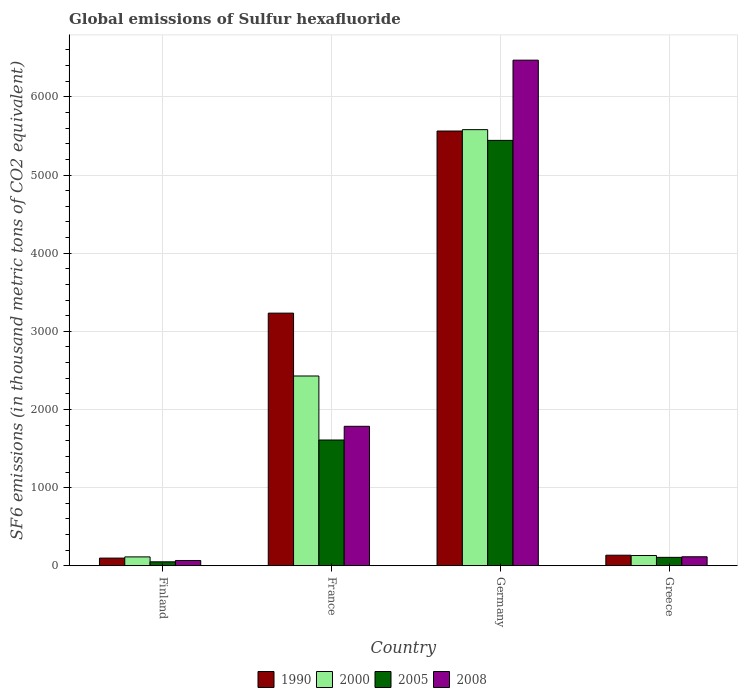How many different coloured bars are there?
Ensure brevity in your answer.  4. How many groups of bars are there?
Your answer should be very brief. 4. Are the number of bars per tick equal to the number of legend labels?
Your answer should be very brief. Yes. Are the number of bars on each tick of the X-axis equal?
Your answer should be compact. Yes. How many bars are there on the 3rd tick from the left?
Offer a very short reply. 4. What is the label of the 1st group of bars from the left?
Provide a succinct answer. Finland. What is the global emissions of Sulfur hexafluoride in 2000 in France?
Provide a short and direct response. 2428.5. Across all countries, what is the maximum global emissions of Sulfur hexafluoride in 2000?
Your response must be concise. 5580.4. Across all countries, what is the minimum global emissions of Sulfur hexafluoride in 2008?
Provide a short and direct response. 67.9. In which country was the global emissions of Sulfur hexafluoride in 2008 maximum?
Offer a very short reply. Germany. In which country was the global emissions of Sulfur hexafluoride in 2005 minimum?
Your answer should be very brief. Finland. What is the total global emissions of Sulfur hexafluoride in 2000 in the graph?
Your answer should be very brief. 8254.6. What is the difference between the global emissions of Sulfur hexafluoride in 2000 in Germany and that in Greece?
Your answer should be compact. 5448.6. What is the difference between the global emissions of Sulfur hexafluoride in 1990 in France and the global emissions of Sulfur hexafluoride in 2008 in Greece?
Offer a very short reply. 3117.4. What is the average global emissions of Sulfur hexafluoride in 1990 per country?
Your response must be concise. 2257.38. What is the difference between the global emissions of Sulfur hexafluoride of/in 2000 and global emissions of Sulfur hexafluoride of/in 2005 in Finland?
Your answer should be very brief. 63. What is the ratio of the global emissions of Sulfur hexafluoride in 2008 in Finland to that in France?
Give a very brief answer. 0.04. Is the difference between the global emissions of Sulfur hexafluoride in 2000 in Germany and Greece greater than the difference between the global emissions of Sulfur hexafluoride in 2005 in Germany and Greece?
Provide a succinct answer. Yes. What is the difference between the highest and the second highest global emissions of Sulfur hexafluoride in 2005?
Your response must be concise. -3833.8. What is the difference between the highest and the lowest global emissions of Sulfur hexafluoride in 2005?
Offer a terse response. 5392.3. In how many countries, is the global emissions of Sulfur hexafluoride in 2008 greater than the average global emissions of Sulfur hexafluoride in 2008 taken over all countries?
Your answer should be very brief. 1. What does the 2nd bar from the right in France represents?
Your response must be concise. 2005. How many bars are there?
Provide a succinct answer. 16. What is the difference between two consecutive major ticks on the Y-axis?
Your answer should be compact. 1000. Where does the legend appear in the graph?
Ensure brevity in your answer.  Bottom center. How are the legend labels stacked?
Offer a terse response. Horizontal. What is the title of the graph?
Give a very brief answer. Global emissions of Sulfur hexafluoride. What is the label or title of the X-axis?
Offer a very short reply. Country. What is the label or title of the Y-axis?
Your answer should be very brief. SF6 emissions (in thousand metric tons of CO2 equivalent). What is the SF6 emissions (in thousand metric tons of CO2 equivalent) of 1990 in Finland?
Offer a very short reply. 98.4. What is the SF6 emissions (in thousand metric tons of CO2 equivalent) of 2000 in Finland?
Keep it short and to the point. 113.9. What is the SF6 emissions (in thousand metric tons of CO2 equivalent) in 2005 in Finland?
Your answer should be compact. 50.9. What is the SF6 emissions (in thousand metric tons of CO2 equivalent) of 2008 in Finland?
Ensure brevity in your answer.  67.9. What is the SF6 emissions (in thousand metric tons of CO2 equivalent) in 1990 in France?
Make the answer very short. 3232.8. What is the SF6 emissions (in thousand metric tons of CO2 equivalent) of 2000 in France?
Provide a short and direct response. 2428.5. What is the SF6 emissions (in thousand metric tons of CO2 equivalent) of 2005 in France?
Make the answer very short. 1609.4. What is the SF6 emissions (in thousand metric tons of CO2 equivalent) of 2008 in France?
Your response must be concise. 1784.7. What is the SF6 emissions (in thousand metric tons of CO2 equivalent) in 1990 in Germany?
Offer a terse response. 5562.9. What is the SF6 emissions (in thousand metric tons of CO2 equivalent) in 2000 in Germany?
Your response must be concise. 5580.4. What is the SF6 emissions (in thousand metric tons of CO2 equivalent) of 2005 in Germany?
Your answer should be compact. 5443.2. What is the SF6 emissions (in thousand metric tons of CO2 equivalent) of 2008 in Germany?
Offer a terse response. 6469.6. What is the SF6 emissions (in thousand metric tons of CO2 equivalent) in 1990 in Greece?
Your answer should be very brief. 135.4. What is the SF6 emissions (in thousand metric tons of CO2 equivalent) of 2000 in Greece?
Ensure brevity in your answer.  131.8. What is the SF6 emissions (in thousand metric tons of CO2 equivalent) of 2005 in Greece?
Offer a terse response. 108.1. What is the SF6 emissions (in thousand metric tons of CO2 equivalent) of 2008 in Greece?
Give a very brief answer. 115.4. Across all countries, what is the maximum SF6 emissions (in thousand metric tons of CO2 equivalent) in 1990?
Provide a succinct answer. 5562.9. Across all countries, what is the maximum SF6 emissions (in thousand metric tons of CO2 equivalent) of 2000?
Make the answer very short. 5580.4. Across all countries, what is the maximum SF6 emissions (in thousand metric tons of CO2 equivalent) of 2005?
Your answer should be compact. 5443.2. Across all countries, what is the maximum SF6 emissions (in thousand metric tons of CO2 equivalent) of 2008?
Offer a terse response. 6469.6. Across all countries, what is the minimum SF6 emissions (in thousand metric tons of CO2 equivalent) in 1990?
Keep it short and to the point. 98.4. Across all countries, what is the minimum SF6 emissions (in thousand metric tons of CO2 equivalent) of 2000?
Ensure brevity in your answer.  113.9. Across all countries, what is the minimum SF6 emissions (in thousand metric tons of CO2 equivalent) in 2005?
Your response must be concise. 50.9. Across all countries, what is the minimum SF6 emissions (in thousand metric tons of CO2 equivalent) in 2008?
Offer a very short reply. 67.9. What is the total SF6 emissions (in thousand metric tons of CO2 equivalent) of 1990 in the graph?
Ensure brevity in your answer.  9029.5. What is the total SF6 emissions (in thousand metric tons of CO2 equivalent) of 2000 in the graph?
Keep it short and to the point. 8254.6. What is the total SF6 emissions (in thousand metric tons of CO2 equivalent) in 2005 in the graph?
Your response must be concise. 7211.6. What is the total SF6 emissions (in thousand metric tons of CO2 equivalent) in 2008 in the graph?
Give a very brief answer. 8437.6. What is the difference between the SF6 emissions (in thousand metric tons of CO2 equivalent) in 1990 in Finland and that in France?
Offer a very short reply. -3134.4. What is the difference between the SF6 emissions (in thousand metric tons of CO2 equivalent) of 2000 in Finland and that in France?
Make the answer very short. -2314.6. What is the difference between the SF6 emissions (in thousand metric tons of CO2 equivalent) of 2005 in Finland and that in France?
Give a very brief answer. -1558.5. What is the difference between the SF6 emissions (in thousand metric tons of CO2 equivalent) in 2008 in Finland and that in France?
Keep it short and to the point. -1716.8. What is the difference between the SF6 emissions (in thousand metric tons of CO2 equivalent) in 1990 in Finland and that in Germany?
Your answer should be compact. -5464.5. What is the difference between the SF6 emissions (in thousand metric tons of CO2 equivalent) in 2000 in Finland and that in Germany?
Give a very brief answer. -5466.5. What is the difference between the SF6 emissions (in thousand metric tons of CO2 equivalent) in 2005 in Finland and that in Germany?
Provide a succinct answer. -5392.3. What is the difference between the SF6 emissions (in thousand metric tons of CO2 equivalent) of 2008 in Finland and that in Germany?
Give a very brief answer. -6401.7. What is the difference between the SF6 emissions (in thousand metric tons of CO2 equivalent) of 1990 in Finland and that in Greece?
Make the answer very short. -37. What is the difference between the SF6 emissions (in thousand metric tons of CO2 equivalent) of 2000 in Finland and that in Greece?
Keep it short and to the point. -17.9. What is the difference between the SF6 emissions (in thousand metric tons of CO2 equivalent) in 2005 in Finland and that in Greece?
Keep it short and to the point. -57.2. What is the difference between the SF6 emissions (in thousand metric tons of CO2 equivalent) in 2008 in Finland and that in Greece?
Offer a very short reply. -47.5. What is the difference between the SF6 emissions (in thousand metric tons of CO2 equivalent) in 1990 in France and that in Germany?
Ensure brevity in your answer.  -2330.1. What is the difference between the SF6 emissions (in thousand metric tons of CO2 equivalent) of 2000 in France and that in Germany?
Offer a very short reply. -3151.9. What is the difference between the SF6 emissions (in thousand metric tons of CO2 equivalent) in 2005 in France and that in Germany?
Make the answer very short. -3833.8. What is the difference between the SF6 emissions (in thousand metric tons of CO2 equivalent) in 2008 in France and that in Germany?
Your response must be concise. -4684.9. What is the difference between the SF6 emissions (in thousand metric tons of CO2 equivalent) in 1990 in France and that in Greece?
Your response must be concise. 3097.4. What is the difference between the SF6 emissions (in thousand metric tons of CO2 equivalent) of 2000 in France and that in Greece?
Your answer should be compact. 2296.7. What is the difference between the SF6 emissions (in thousand metric tons of CO2 equivalent) in 2005 in France and that in Greece?
Your answer should be very brief. 1501.3. What is the difference between the SF6 emissions (in thousand metric tons of CO2 equivalent) in 2008 in France and that in Greece?
Provide a short and direct response. 1669.3. What is the difference between the SF6 emissions (in thousand metric tons of CO2 equivalent) of 1990 in Germany and that in Greece?
Make the answer very short. 5427.5. What is the difference between the SF6 emissions (in thousand metric tons of CO2 equivalent) in 2000 in Germany and that in Greece?
Make the answer very short. 5448.6. What is the difference between the SF6 emissions (in thousand metric tons of CO2 equivalent) of 2005 in Germany and that in Greece?
Offer a very short reply. 5335.1. What is the difference between the SF6 emissions (in thousand metric tons of CO2 equivalent) in 2008 in Germany and that in Greece?
Provide a short and direct response. 6354.2. What is the difference between the SF6 emissions (in thousand metric tons of CO2 equivalent) in 1990 in Finland and the SF6 emissions (in thousand metric tons of CO2 equivalent) in 2000 in France?
Give a very brief answer. -2330.1. What is the difference between the SF6 emissions (in thousand metric tons of CO2 equivalent) of 1990 in Finland and the SF6 emissions (in thousand metric tons of CO2 equivalent) of 2005 in France?
Give a very brief answer. -1511. What is the difference between the SF6 emissions (in thousand metric tons of CO2 equivalent) of 1990 in Finland and the SF6 emissions (in thousand metric tons of CO2 equivalent) of 2008 in France?
Your response must be concise. -1686.3. What is the difference between the SF6 emissions (in thousand metric tons of CO2 equivalent) in 2000 in Finland and the SF6 emissions (in thousand metric tons of CO2 equivalent) in 2005 in France?
Provide a short and direct response. -1495.5. What is the difference between the SF6 emissions (in thousand metric tons of CO2 equivalent) in 2000 in Finland and the SF6 emissions (in thousand metric tons of CO2 equivalent) in 2008 in France?
Your response must be concise. -1670.8. What is the difference between the SF6 emissions (in thousand metric tons of CO2 equivalent) of 2005 in Finland and the SF6 emissions (in thousand metric tons of CO2 equivalent) of 2008 in France?
Ensure brevity in your answer.  -1733.8. What is the difference between the SF6 emissions (in thousand metric tons of CO2 equivalent) in 1990 in Finland and the SF6 emissions (in thousand metric tons of CO2 equivalent) in 2000 in Germany?
Your answer should be very brief. -5482. What is the difference between the SF6 emissions (in thousand metric tons of CO2 equivalent) of 1990 in Finland and the SF6 emissions (in thousand metric tons of CO2 equivalent) of 2005 in Germany?
Your answer should be compact. -5344.8. What is the difference between the SF6 emissions (in thousand metric tons of CO2 equivalent) of 1990 in Finland and the SF6 emissions (in thousand metric tons of CO2 equivalent) of 2008 in Germany?
Give a very brief answer. -6371.2. What is the difference between the SF6 emissions (in thousand metric tons of CO2 equivalent) in 2000 in Finland and the SF6 emissions (in thousand metric tons of CO2 equivalent) in 2005 in Germany?
Keep it short and to the point. -5329.3. What is the difference between the SF6 emissions (in thousand metric tons of CO2 equivalent) of 2000 in Finland and the SF6 emissions (in thousand metric tons of CO2 equivalent) of 2008 in Germany?
Provide a succinct answer. -6355.7. What is the difference between the SF6 emissions (in thousand metric tons of CO2 equivalent) in 2005 in Finland and the SF6 emissions (in thousand metric tons of CO2 equivalent) in 2008 in Germany?
Your answer should be compact. -6418.7. What is the difference between the SF6 emissions (in thousand metric tons of CO2 equivalent) in 1990 in Finland and the SF6 emissions (in thousand metric tons of CO2 equivalent) in 2000 in Greece?
Your answer should be compact. -33.4. What is the difference between the SF6 emissions (in thousand metric tons of CO2 equivalent) of 2000 in Finland and the SF6 emissions (in thousand metric tons of CO2 equivalent) of 2005 in Greece?
Give a very brief answer. 5.8. What is the difference between the SF6 emissions (in thousand metric tons of CO2 equivalent) in 2000 in Finland and the SF6 emissions (in thousand metric tons of CO2 equivalent) in 2008 in Greece?
Make the answer very short. -1.5. What is the difference between the SF6 emissions (in thousand metric tons of CO2 equivalent) of 2005 in Finland and the SF6 emissions (in thousand metric tons of CO2 equivalent) of 2008 in Greece?
Your answer should be very brief. -64.5. What is the difference between the SF6 emissions (in thousand metric tons of CO2 equivalent) in 1990 in France and the SF6 emissions (in thousand metric tons of CO2 equivalent) in 2000 in Germany?
Ensure brevity in your answer.  -2347.6. What is the difference between the SF6 emissions (in thousand metric tons of CO2 equivalent) of 1990 in France and the SF6 emissions (in thousand metric tons of CO2 equivalent) of 2005 in Germany?
Give a very brief answer. -2210.4. What is the difference between the SF6 emissions (in thousand metric tons of CO2 equivalent) of 1990 in France and the SF6 emissions (in thousand metric tons of CO2 equivalent) of 2008 in Germany?
Give a very brief answer. -3236.8. What is the difference between the SF6 emissions (in thousand metric tons of CO2 equivalent) of 2000 in France and the SF6 emissions (in thousand metric tons of CO2 equivalent) of 2005 in Germany?
Keep it short and to the point. -3014.7. What is the difference between the SF6 emissions (in thousand metric tons of CO2 equivalent) of 2000 in France and the SF6 emissions (in thousand metric tons of CO2 equivalent) of 2008 in Germany?
Give a very brief answer. -4041.1. What is the difference between the SF6 emissions (in thousand metric tons of CO2 equivalent) in 2005 in France and the SF6 emissions (in thousand metric tons of CO2 equivalent) in 2008 in Germany?
Give a very brief answer. -4860.2. What is the difference between the SF6 emissions (in thousand metric tons of CO2 equivalent) in 1990 in France and the SF6 emissions (in thousand metric tons of CO2 equivalent) in 2000 in Greece?
Your answer should be very brief. 3101. What is the difference between the SF6 emissions (in thousand metric tons of CO2 equivalent) in 1990 in France and the SF6 emissions (in thousand metric tons of CO2 equivalent) in 2005 in Greece?
Offer a very short reply. 3124.7. What is the difference between the SF6 emissions (in thousand metric tons of CO2 equivalent) in 1990 in France and the SF6 emissions (in thousand metric tons of CO2 equivalent) in 2008 in Greece?
Your answer should be compact. 3117.4. What is the difference between the SF6 emissions (in thousand metric tons of CO2 equivalent) of 2000 in France and the SF6 emissions (in thousand metric tons of CO2 equivalent) of 2005 in Greece?
Give a very brief answer. 2320.4. What is the difference between the SF6 emissions (in thousand metric tons of CO2 equivalent) of 2000 in France and the SF6 emissions (in thousand metric tons of CO2 equivalent) of 2008 in Greece?
Provide a succinct answer. 2313.1. What is the difference between the SF6 emissions (in thousand metric tons of CO2 equivalent) in 2005 in France and the SF6 emissions (in thousand metric tons of CO2 equivalent) in 2008 in Greece?
Provide a succinct answer. 1494. What is the difference between the SF6 emissions (in thousand metric tons of CO2 equivalent) of 1990 in Germany and the SF6 emissions (in thousand metric tons of CO2 equivalent) of 2000 in Greece?
Provide a succinct answer. 5431.1. What is the difference between the SF6 emissions (in thousand metric tons of CO2 equivalent) in 1990 in Germany and the SF6 emissions (in thousand metric tons of CO2 equivalent) in 2005 in Greece?
Offer a terse response. 5454.8. What is the difference between the SF6 emissions (in thousand metric tons of CO2 equivalent) in 1990 in Germany and the SF6 emissions (in thousand metric tons of CO2 equivalent) in 2008 in Greece?
Ensure brevity in your answer.  5447.5. What is the difference between the SF6 emissions (in thousand metric tons of CO2 equivalent) in 2000 in Germany and the SF6 emissions (in thousand metric tons of CO2 equivalent) in 2005 in Greece?
Offer a very short reply. 5472.3. What is the difference between the SF6 emissions (in thousand metric tons of CO2 equivalent) in 2000 in Germany and the SF6 emissions (in thousand metric tons of CO2 equivalent) in 2008 in Greece?
Provide a succinct answer. 5465. What is the difference between the SF6 emissions (in thousand metric tons of CO2 equivalent) in 2005 in Germany and the SF6 emissions (in thousand metric tons of CO2 equivalent) in 2008 in Greece?
Provide a short and direct response. 5327.8. What is the average SF6 emissions (in thousand metric tons of CO2 equivalent) of 1990 per country?
Offer a terse response. 2257.38. What is the average SF6 emissions (in thousand metric tons of CO2 equivalent) in 2000 per country?
Your answer should be compact. 2063.65. What is the average SF6 emissions (in thousand metric tons of CO2 equivalent) of 2005 per country?
Your answer should be compact. 1802.9. What is the average SF6 emissions (in thousand metric tons of CO2 equivalent) in 2008 per country?
Make the answer very short. 2109.4. What is the difference between the SF6 emissions (in thousand metric tons of CO2 equivalent) in 1990 and SF6 emissions (in thousand metric tons of CO2 equivalent) in 2000 in Finland?
Give a very brief answer. -15.5. What is the difference between the SF6 emissions (in thousand metric tons of CO2 equivalent) in 1990 and SF6 emissions (in thousand metric tons of CO2 equivalent) in 2005 in Finland?
Make the answer very short. 47.5. What is the difference between the SF6 emissions (in thousand metric tons of CO2 equivalent) of 1990 and SF6 emissions (in thousand metric tons of CO2 equivalent) of 2008 in Finland?
Provide a short and direct response. 30.5. What is the difference between the SF6 emissions (in thousand metric tons of CO2 equivalent) of 2000 and SF6 emissions (in thousand metric tons of CO2 equivalent) of 2005 in Finland?
Your answer should be very brief. 63. What is the difference between the SF6 emissions (in thousand metric tons of CO2 equivalent) of 2005 and SF6 emissions (in thousand metric tons of CO2 equivalent) of 2008 in Finland?
Provide a succinct answer. -17. What is the difference between the SF6 emissions (in thousand metric tons of CO2 equivalent) of 1990 and SF6 emissions (in thousand metric tons of CO2 equivalent) of 2000 in France?
Your response must be concise. 804.3. What is the difference between the SF6 emissions (in thousand metric tons of CO2 equivalent) of 1990 and SF6 emissions (in thousand metric tons of CO2 equivalent) of 2005 in France?
Provide a short and direct response. 1623.4. What is the difference between the SF6 emissions (in thousand metric tons of CO2 equivalent) in 1990 and SF6 emissions (in thousand metric tons of CO2 equivalent) in 2008 in France?
Give a very brief answer. 1448.1. What is the difference between the SF6 emissions (in thousand metric tons of CO2 equivalent) of 2000 and SF6 emissions (in thousand metric tons of CO2 equivalent) of 2005 in France?
Offer a very short reply. 819.1. What is the difference between the SF6 emissions (in thousand metric tons of CO2 equivalent) in 2000 and SF6 emissions (in thousand metric tons of CO2 equivalent) in 2008 in France?
Provide a short and direct response. 643.8. What is the difference between the SF6 emissions (in thousand metric tons of CO2 equivalent) in 2005 and SF6 emissions (in thousand metric tons of CO2 equivalent) in 2008 in France?
Ensure brevity in your answer.  -175.3. What is the difference between the SF6 emissions (in thousand metric tons of CO2 equivalent) in 1990 and SF6 emissions (in thousand metric tons of CO2 equivalent) in 2000 in Germany?
Your answer should be compact. -17.5. What is the difference between the SF6 emissions (in thousand metric tons of CO2 equivalent) of 1990 and SF6 emissions (in thousand metric tons of CO2 equivalent) of 2005 in Germany?
Your answer should be compact. 119.7. What is the difference between the SF6 emissions (in thousand metric tons of CO2 equivalent) of 1990 and SF6 emissions (in thousand metric tons of CO2 equivalent) of 2008 in Germany?
Provide a succinct answer. -906.7. What is the difference between the SF6 emissions (in thousand metric tons of CO2 equivalent) in 2000 and SF6 emissions (in thousand metric tons of CO2 equivalent) in 2005 in Germany?
Your answer should be compact. 137.2. What is the difference between the SF6 emissions (in thousand metric tons of CO2 equivalent) in 2000 and SF6 emissions (in thousand metric tons of CO2 equivalent) in 2008 in Germany?
Ensure brevity in your answer.  -889.2. What is the difference between the SF6 emissions (in thousand metric tons of CO2 equivalent) in 2005 and SF6 emissions (in thousand metric tons of CO2 equivalent) in 2008 in Germany?
Offer a terse response. -1026.4. What is the difference between the SF6 emissions (in thousand metric tons of CO2 equivalent) of 1990 and SF6 emissions (in thousand metric tons of CO2 equivalent) of 2000 in Greece?
Keep it short and to the point. 3.6. What is the difference between the SF6 emissions (in thousand metric tons of CO2 equivalent) of 1990 and SF6 emissions (in thousand metric tons of CO2 equivalent) of 2005 in Greece?
Your answer should be very brief. 27.3. What is the difference between the SF6 emissions (in thousand metric tons of CO2 equivalent) of 1990 and SF6 emissions (in thousand metric tons of CO2 equivalent) of 2008 in Greece?
Provide a succinct answer. 20. What is the difference between the SF6 emissions (in thousand metric tons of CO2 equivalent) in 2000 and SF6 emissions (in thousand metric tons of CO2 equivalent) in 2005 in Greece?
Offer a very short reply. 23.7. What is the ratio of the SF6 emissions (in thousand metric tons of CO2 equivalent) of 1990 in Finland to that in France?
Keep it short and to the point. 0.03. What is the ratio of the SF6 emissions (in thousand metric tons of CO2 equivalent) of 2000 in Finland to that in France?
Your answer should be compact. 0.05. What is the ratio of the SF6 emissions (in thousand metric tons of CO2 equivalent) of 2005 in Finland to that in France?
Your answer should be compact. 0.03. What is the ratio of the SF6 emissions (in thousand metric tons of CO2 equivalent) of 2008 in Finland to that in France?
Your answer should be compact. 0.04. What is the ratio of the SF6 emissions (in thousand metric tons of CO2 equivalent) in 1990 in Finland to that in Germany?
Give a very brief answer. 0.02. What is the ratio of the SF6 emissions (in thousand metric tons of CO2 equivalent) in 2000 in Finland to that in Germany?
Your response must be concise. 0.02. What is the ratio of the SF6 emissions (in thousand metric tons of CO2 equivalent) of 2005 in Finland to that in Germany?
Offer a terse response. 0.01. What is the ratio of the SF6 emissions (in thousand metric tons of CO2 equivalent) in 2008 in Finland to that in Germany?
Your answer should be very brief. 0.01. What is the ratio of the SF6 emissions (in thousand metric tons of CO2 equivalent) in 1990 in Finland to that in Greece?
Offer a very short reply. 0.73. What is the ratio of the SF6 emissions (in thousand metric tons of CO2 equivalent) in 2000 in Finland to that in Greece?
Provide a succinct answer. 0.86. What is the ratio of the SF6 emissions (in thousand metric tons of CO2 equivalent) of 2005 in Finland to that in Greece?
Your response must be concise. 0.47. What is the ratio of the SF6 emissions (in thousand metric tons of CO2 equivalent) of 2008 in Finland to that in Greece?
Give a very brief answer. 0.59. What is the ratio of the SF6 emissions (in thousand metric tons of CO2 equivalent) of 1990 in France to that in Germany?
Provide a succinct answer. 0.58. What is the ratio of the SF6 emissions (in thousand metric tons of CO2 equivalent) in 2000 in France to that in Germany?
Ensure brevity in your answer.  0.44. What is the ratio of the SF6 emissions (in thousand metric tons of CO2 equivalent) in 2005 in France to that in Germany?
Keep it short and to the point. 0.3. What is the ratio of the SF6 emissions (in thousand metric tons of CO2 equivalent) in 2008 in France to that in Germany?
Give a very brief answer. 0.28. What is the ratio of the SF6 emissions (in thousand metric tons of CO2 equivalent) in 1990 in France to that in Greece?
Provide a succinct answer. 23.88. What is the ratio of the SF6 emissions (in thousand metric tons of CO2 equivalent) in 2000 in France to that in Greece?
Offer a terse response. 18.43. What is the ratio of the SF6 emissions (in thousand metric tons of CO2 equivalent) of 2005 in France to that in Greece?
Your response must be concise. 14.89. What is the ratio of the SF6 emissions (in thousand metric tons of CO2 equivalent) of 2008 in France to that in Greece?
Offer a terse response. 15.47. What is the ratio of the SF6 emissions (in thousand metric tons of CO2 equivalent) of 1990 in Germany to that in Greece?
Offer a very short reply. 41.08. What is the ratio of the SF6 emissions (in thousand metric tons of CO2 equivalent) of 2000 in Germany to that in Greece?
Provide a short and direct response. 42.34. What is the ratio of the SF6 emissions (in thousand metric tons of CO2 equivalent) in 2005 in Germany to that in Greece?
Your answer should be compact. 50.35. What is the ratio of the SF6 emissions (in thousand metric tons of CO2 equivalent) in 2008 in Germany to that in Greece?
Give a very brief answer. 56.06. What is the difference between the highest and the second highest SF6 emissions (in thousand metric tons of CO2 equivalent) in 1990?
Offer a terse response. 2330.1. What is the difference between the highest and the second highest SF6 emissions (in thousand metric tons of CO2 equivalent) in 2000?
Your response must be concise. 3151.9. What is the difference between the highest and the second highest SF6 emissions (in thousand metric tons of CO2 equivalent) of 2005?
Your answer should be very brief. 3833.8. What is the difference between the highest and the second highest SF6 emissions (in thousand metric tons of CO2 equivalent) of 2008?
Keep it short and to the point. 4684.9. What is the difference between the highest and the lowest SF6 emissions (in thousand metric tons of CO2 equivalent) in 1990?
Give a very brief answer. 5464.5. What is the difference between the highest and the lowest SF6 emissions (in thousand metric tons of CO2 equivalent) in 2000?
Ensure brevity in your answer.  5466.5. What is the difference between the highest and the lowest SF6 emissions (in thousand metric tons of CO2 equivalent) in 2005?
Ensure brevity in your answer.  5392.3. What is the difference between the highest and the lowest SF6 emissions (in thousand metric tons of CO2 equivalent) in 2008?
Offer a terse response. 6401.7. 